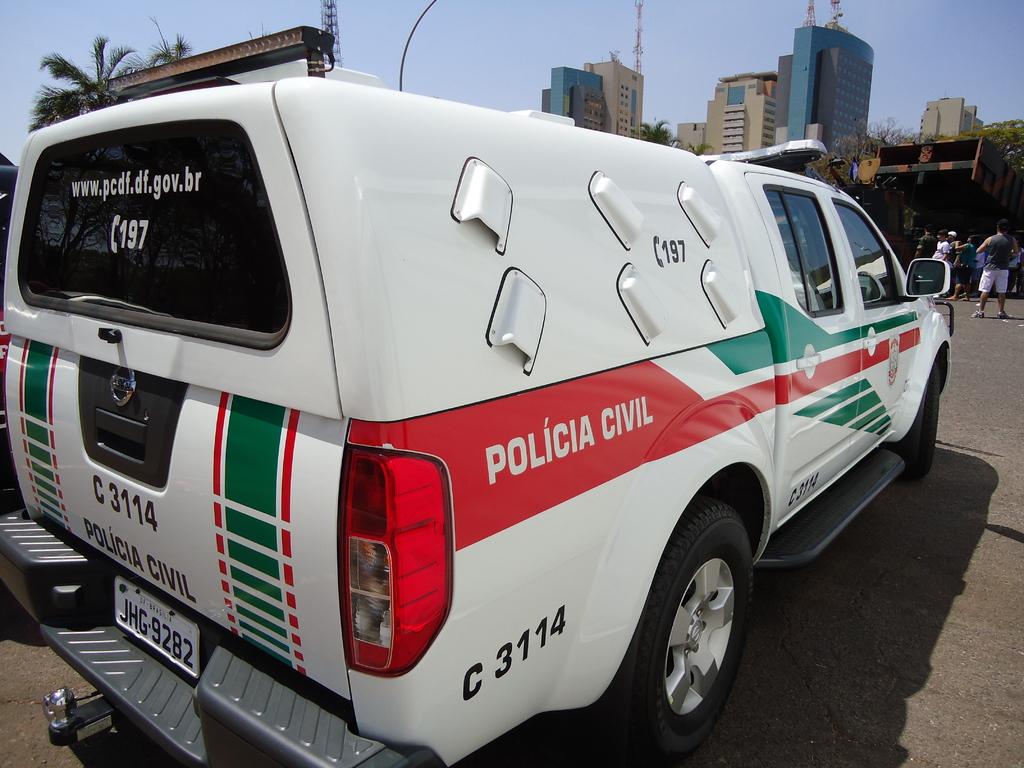What is the license plate number?
Make the answer very short. Jhg 9282. 